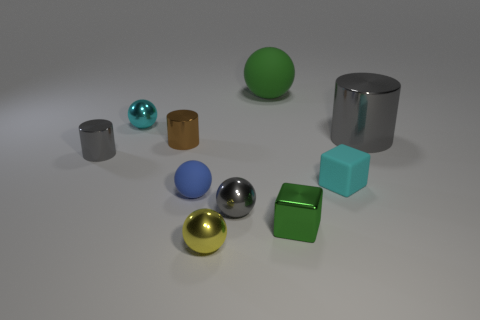Which objects in the scene could potentially weigh more, based on their apparent size and material? The larger objects, such as the big grey cylinder and the large blue sphere, might weigh more due to their volume. Moreover, if we consider the materials, the metallic objects are likely to be heavier than the matte ones of similar size. 